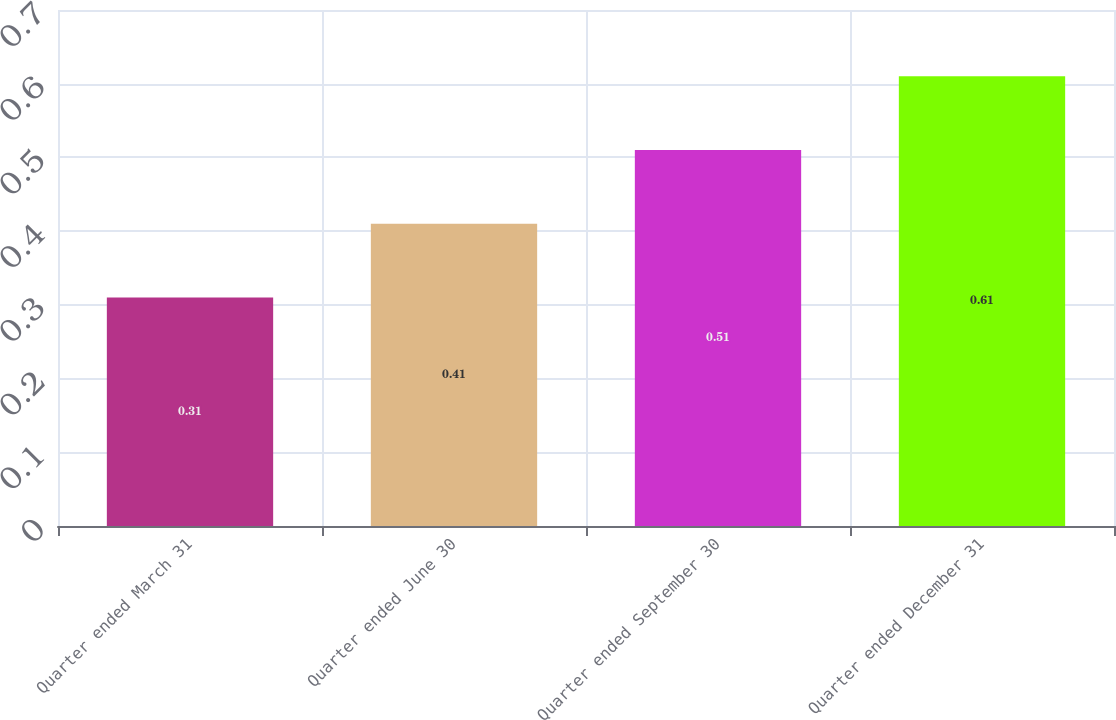Convert chart. <chart><loc_0><loc_0><loc_500><loc_500><bar_chart><fcel>Quarter ended March 31<fcel>Quarter ended June 30<fcel>Quarter ended September 30<fcel>Quarter ended December 31<nl><fcel>0.31<fcel>0.41<fcel>0.51<fcel>0.61<nl></chart> 